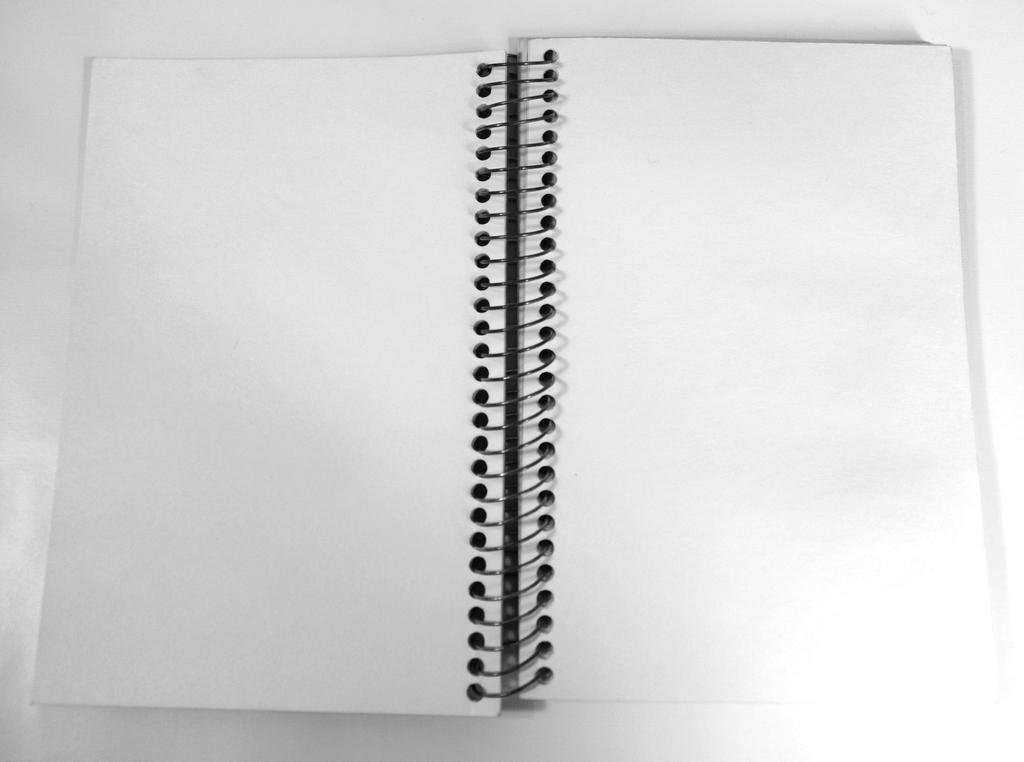Describe this image in one or two sentences. In this image I can see a open book on the table. 